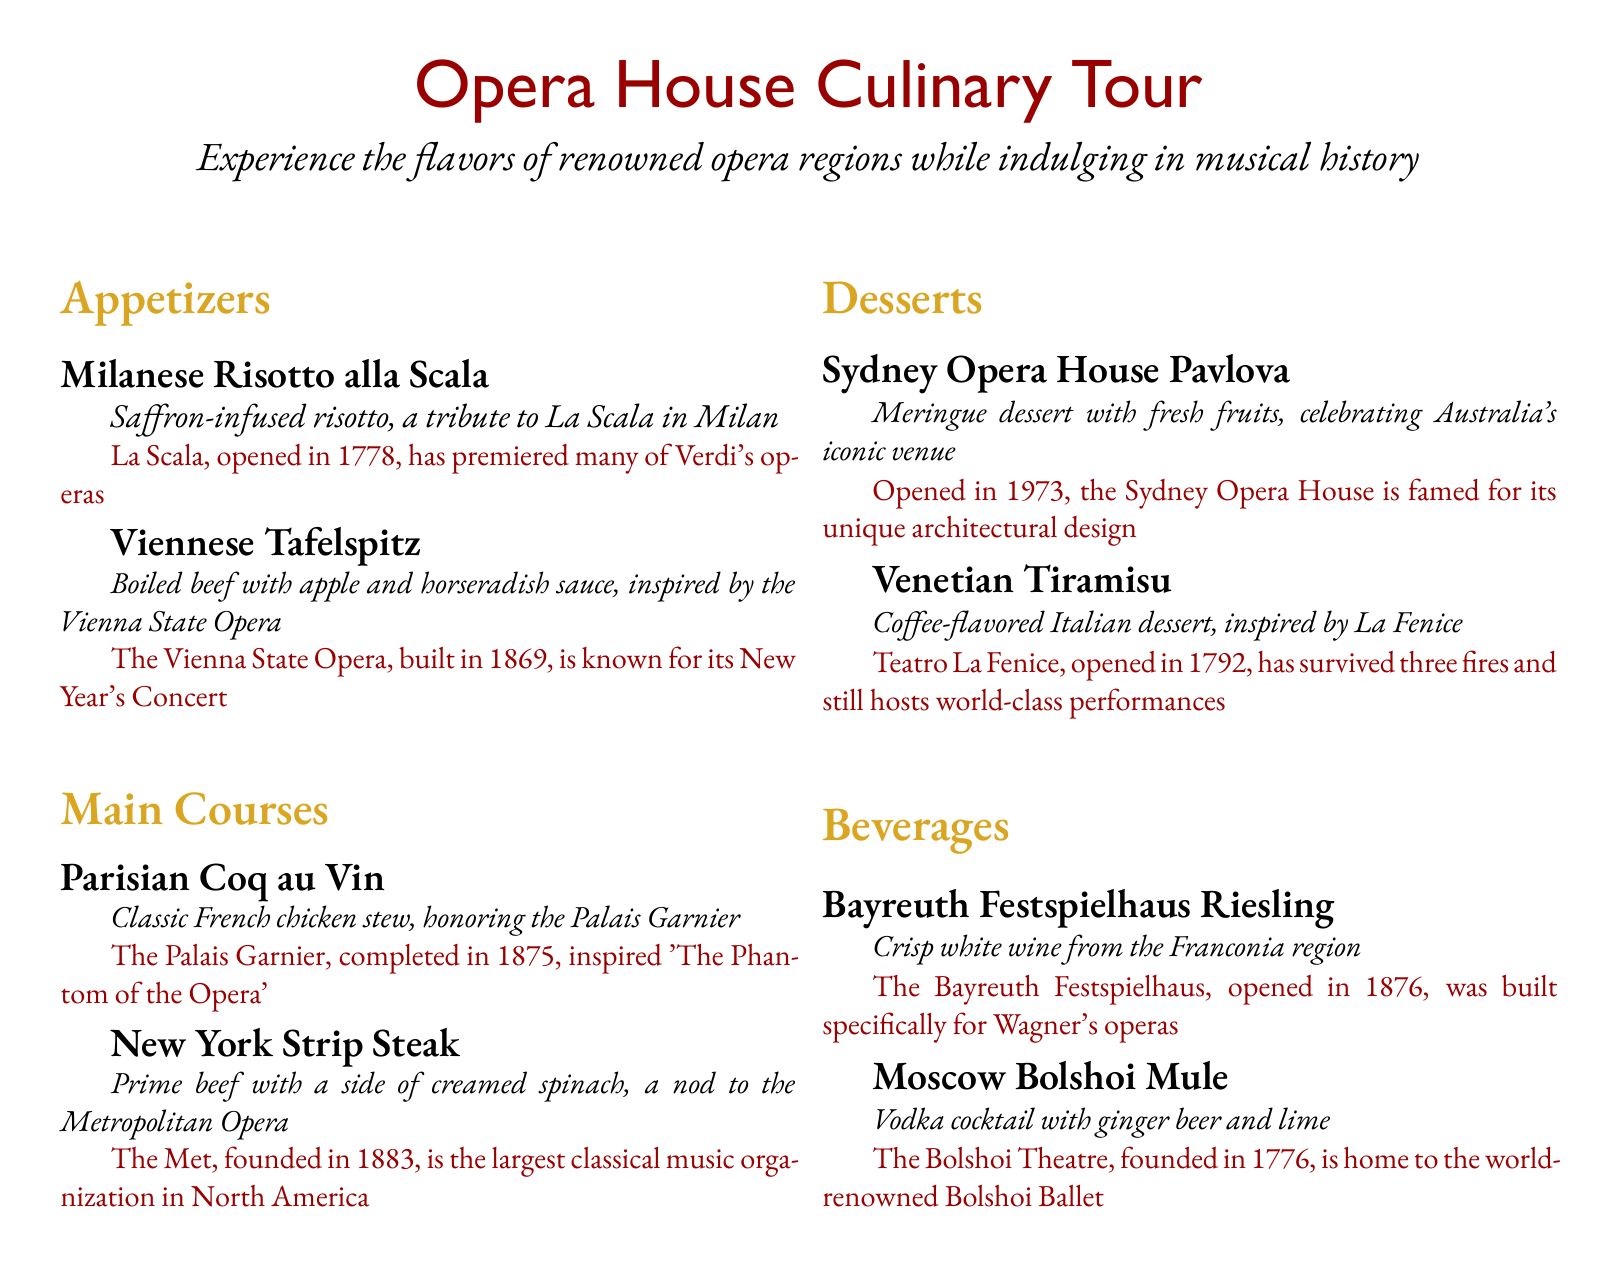What dish pays tribute to La Scala? The dish that pays tribute to La Scala is Milanese Risotto alla Scala.
Answer: Milanese Risotto alla Scala When was the Palais Garnier completed? The Palais Garnier was completed in 1875.
Answer: 1875 Which opera house is associated with Tafelspitz? Tafelspitz is inspired by the Vienna State Opera.
Answer: Vienna State Opera What dessert celebrates the Sydney Opera House? The dessert that celebrates the Sydney Opera House is Pavlova.
Answer: Pavlova How many years after La Fenice opened did the Bayreuth Festspielhaus open? La Fenice opened in 1792 and the Bayreuth Festspielhaus opened in 1876, which is 84 years later.
Answer: 84 years What type of wine is featured from the Bayreuth Festspielhaus? The type of wine featured is Riesling.
Answer: Riesling Which city is the Metropolitan Opera located in? The Metropolitan Opera is located in New York.
Answer: New York What is the main ingredient in Coq au Vin? The main ingredient in Coq au Vin is chicken.
Answer: chicken 